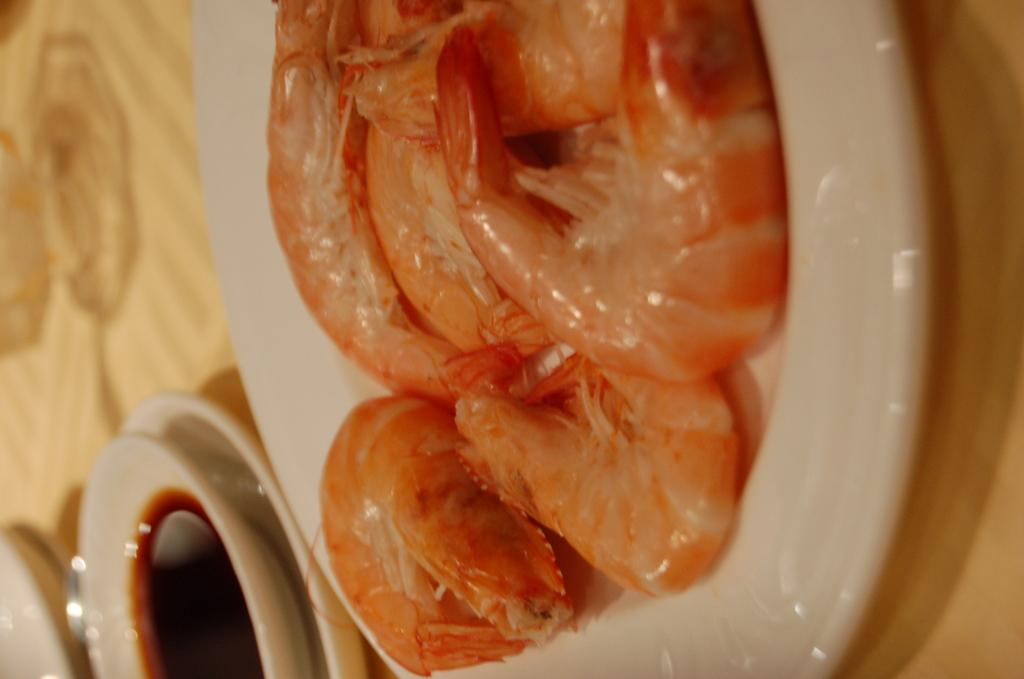What piece of furniture is present in the image? There is a table in the image. What is placed on the table? There is a plate and a bowl on the table. What is on the plate? The plate contains a food item. What is in the bowl? The bowl contains a liquid. How far away is the baseball field from the table in the image? There is no baseball field or any reference to distance in the image. 